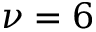<formula> <loc_0><loc_0><loc_500><loc_500>\nu = 6</formula> 